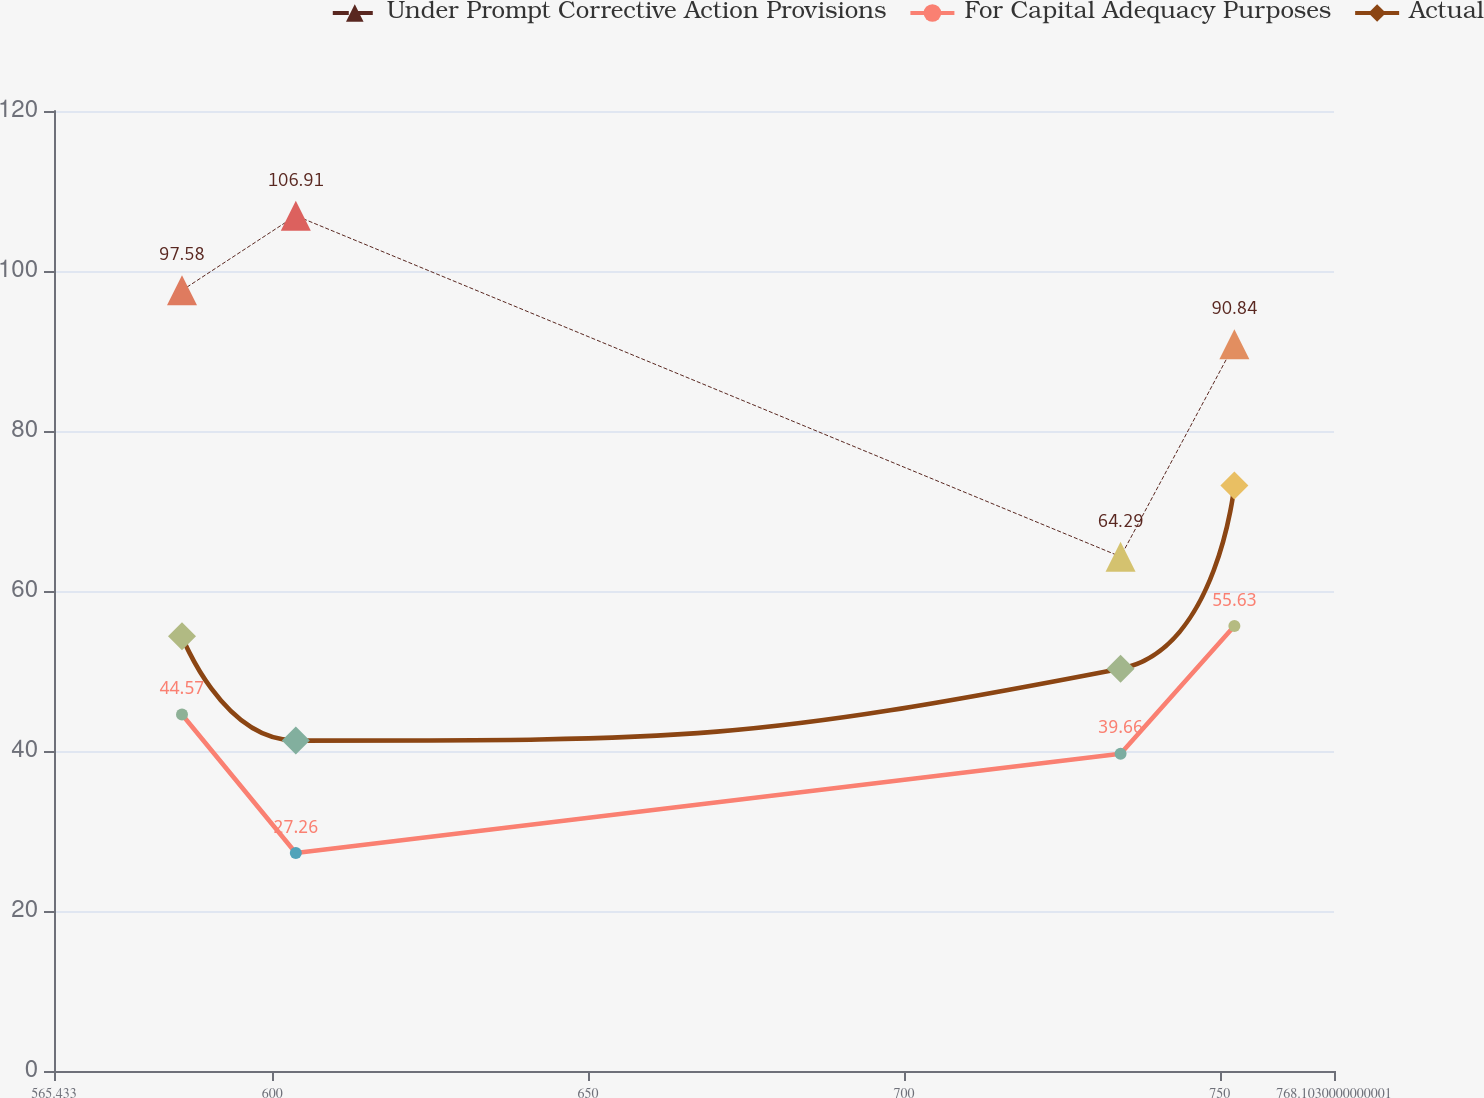Convert chart. <chart><loc_0><loc_0><loc_500><loc_500><line_chart><ecel><fcel>Under Prompt Corrective Action Provisions<fcel>For Capital Adequacy Purposes<fcel>Actual<nl><fcel>585.7<fcel>97.58<fcel>44.57<fcel>54.33<nl><fcel>603.72<fcel>106.91<fcel>27.26<fcel>41.3<nl><fcel>734.31<fcel>64.29<fcel>39.66<fcel>50.29<nl><fcel>752.33<fcel>90.84<fcel>55.63<fcel>73.19<nl><fcel>770.35<fcel>113.65<fcel>30.1<fcel>35.49<nl><fcel>788.37<fcel>43.48<fcel>48.17<fcel>77.23<nl></chart> 